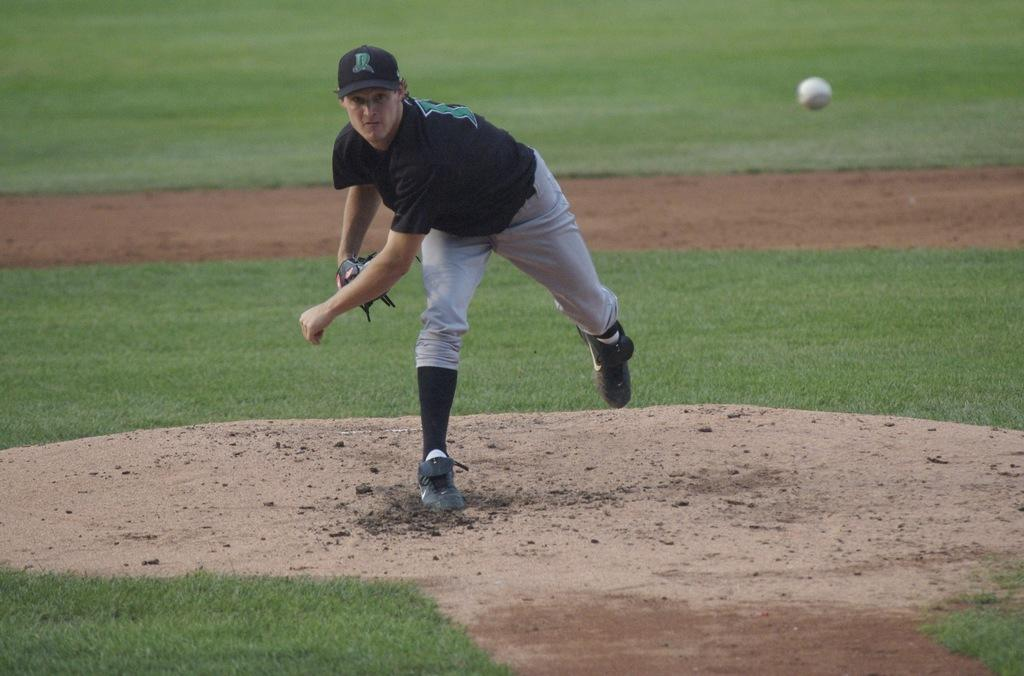Who is the main subject in the image? There is a man in the image. What is the man doing in the image? The man is standing on the ground and throwing a ball. What type of surface is the man standing on? There is sand and grass on the ground in the image. Who is the owner of the crook in the image? There is no crook present in the image. What does the man look like in the image? The provided facts do not give a detailed description of the man's appearance, so we cannot answer this question definitively. 